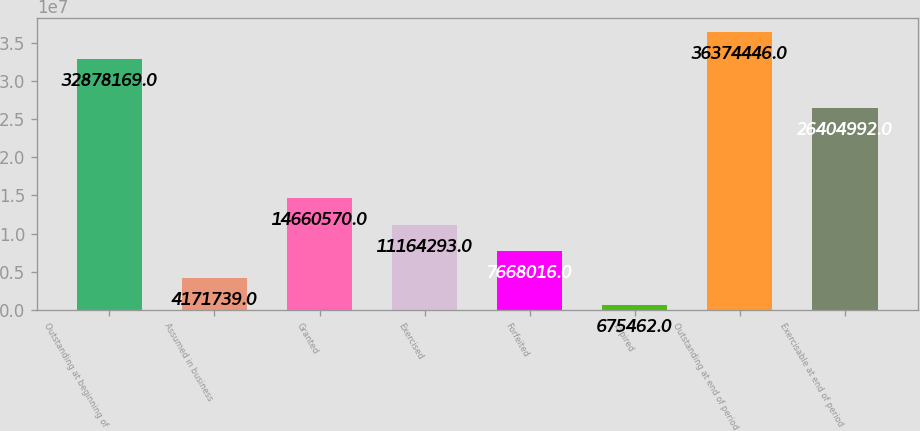Convert chart to OTSL. <chart><loc_0><loc_0><loc_500><loc_500><bar_chart><fcel>Outstanding at beginning of<fcel>Assumed in business<fcel>Granted<fcel>Exercised<fcel>Forfeited<fcel>Expired<fcel>Outstanding at end of period<fcel>Exercisable at end of period<nl><fcel>3.28782e+07<fcel>4.17174e+06<fcel>1.46606e+07<fcel>1.11643e+07<fcel>7.66802e+06<fcel>675462<fcel>3.63744e+07<fcel>2.6405e+07<nl></chart> 